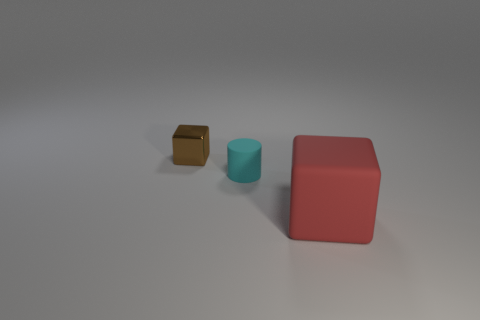Add 2 metal things. How many objects exist? 5 Subtract all cylinders. How many objects are left? 2 Add 2 small cyan cylinders. How many small cyan cylinders are left? 3 Add 3 blue metal things. How many blue metal things exist? 3 Subtract 0 green cylinders. How many objects are left? 3 Subtract all small yellow rubber spheres. Subtract all small things. How many objects are left? 1 